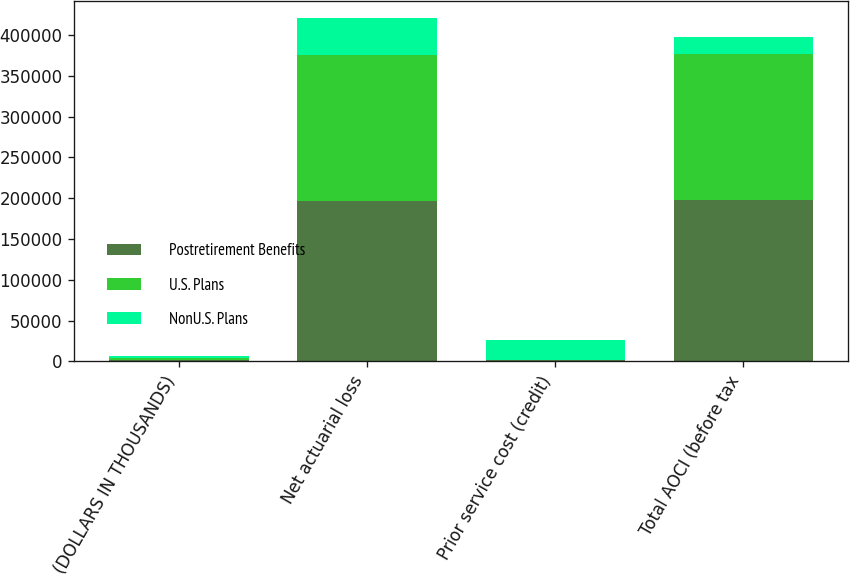<chart> <loc_0><loc_0><loc_500><loc_500><stacked_bar_chart><ecel><fcel>(DOLLARS IN THOUSANDS)<fcel>Net actuarial loss<fcel>Prior service cost (credit)<fcel>Total AOCI (before tax<nl><fcel>Postretirement Benefits<fcel>2011<fcel>196398<fcel>1156<fcel>197554<nl><fcel>U.S. Plans<fcel>2011<fcel>179512<fcel>307<fcel>179205<nl><fcel>NonU.S. Plans<fcel>2011<fcel>44959<fcel>24440<fcel>20519<nl></chart> 